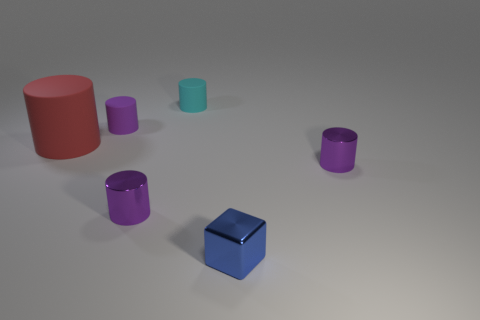There is a purple object behind the large thing; does it have the same shape as the metal object on the right side of the blue thing? Yes, the purple object behind the large cylinder has the same cylindrical shape as the metal object to the right of the blue cube. Both share the characteristic of a circular base and a height that makes them three-dimensional cylinders. 